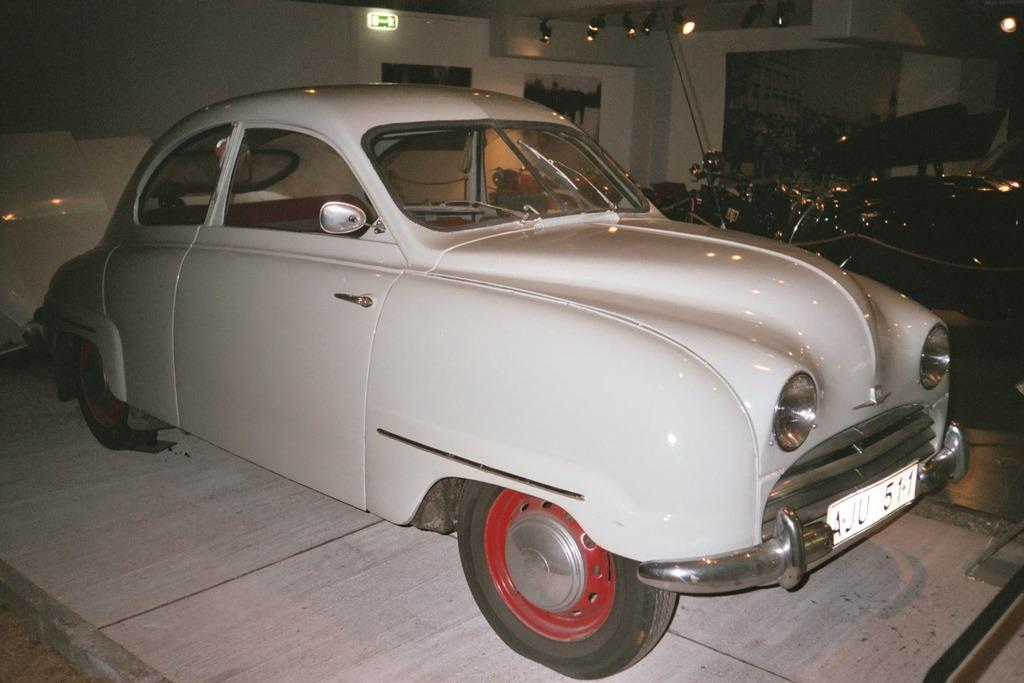What type of vehicles can be seen in the image? There are cars in the image. Can you describe the background of the image? There are lights visible in the background of the image. Where is the hen located in the image? There is no hen present in the image. What type of ship can be seen in the image? There is no ship present in the image. 